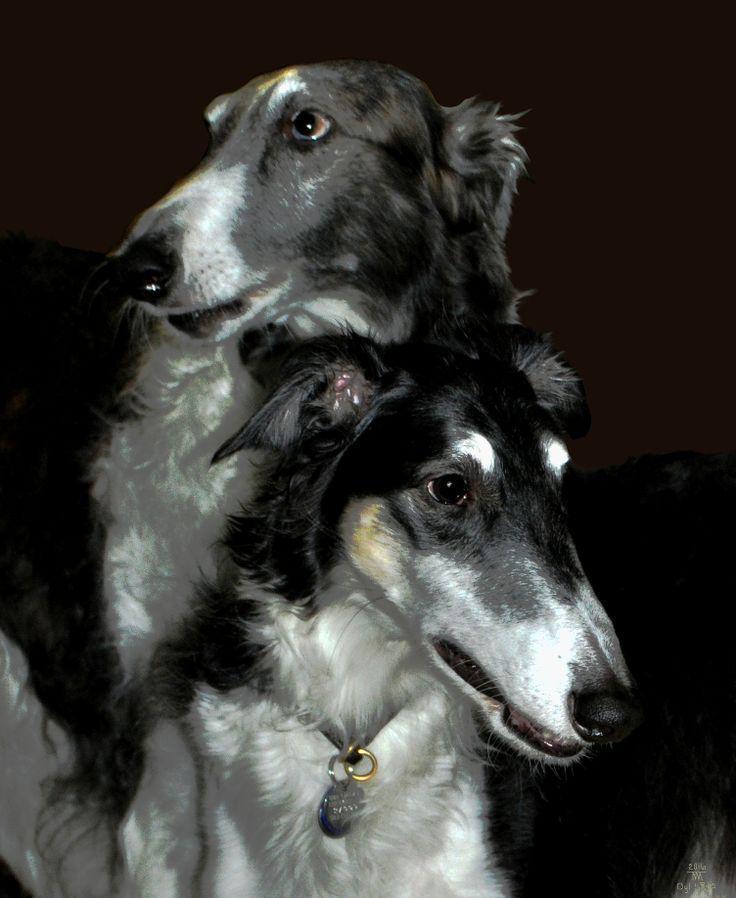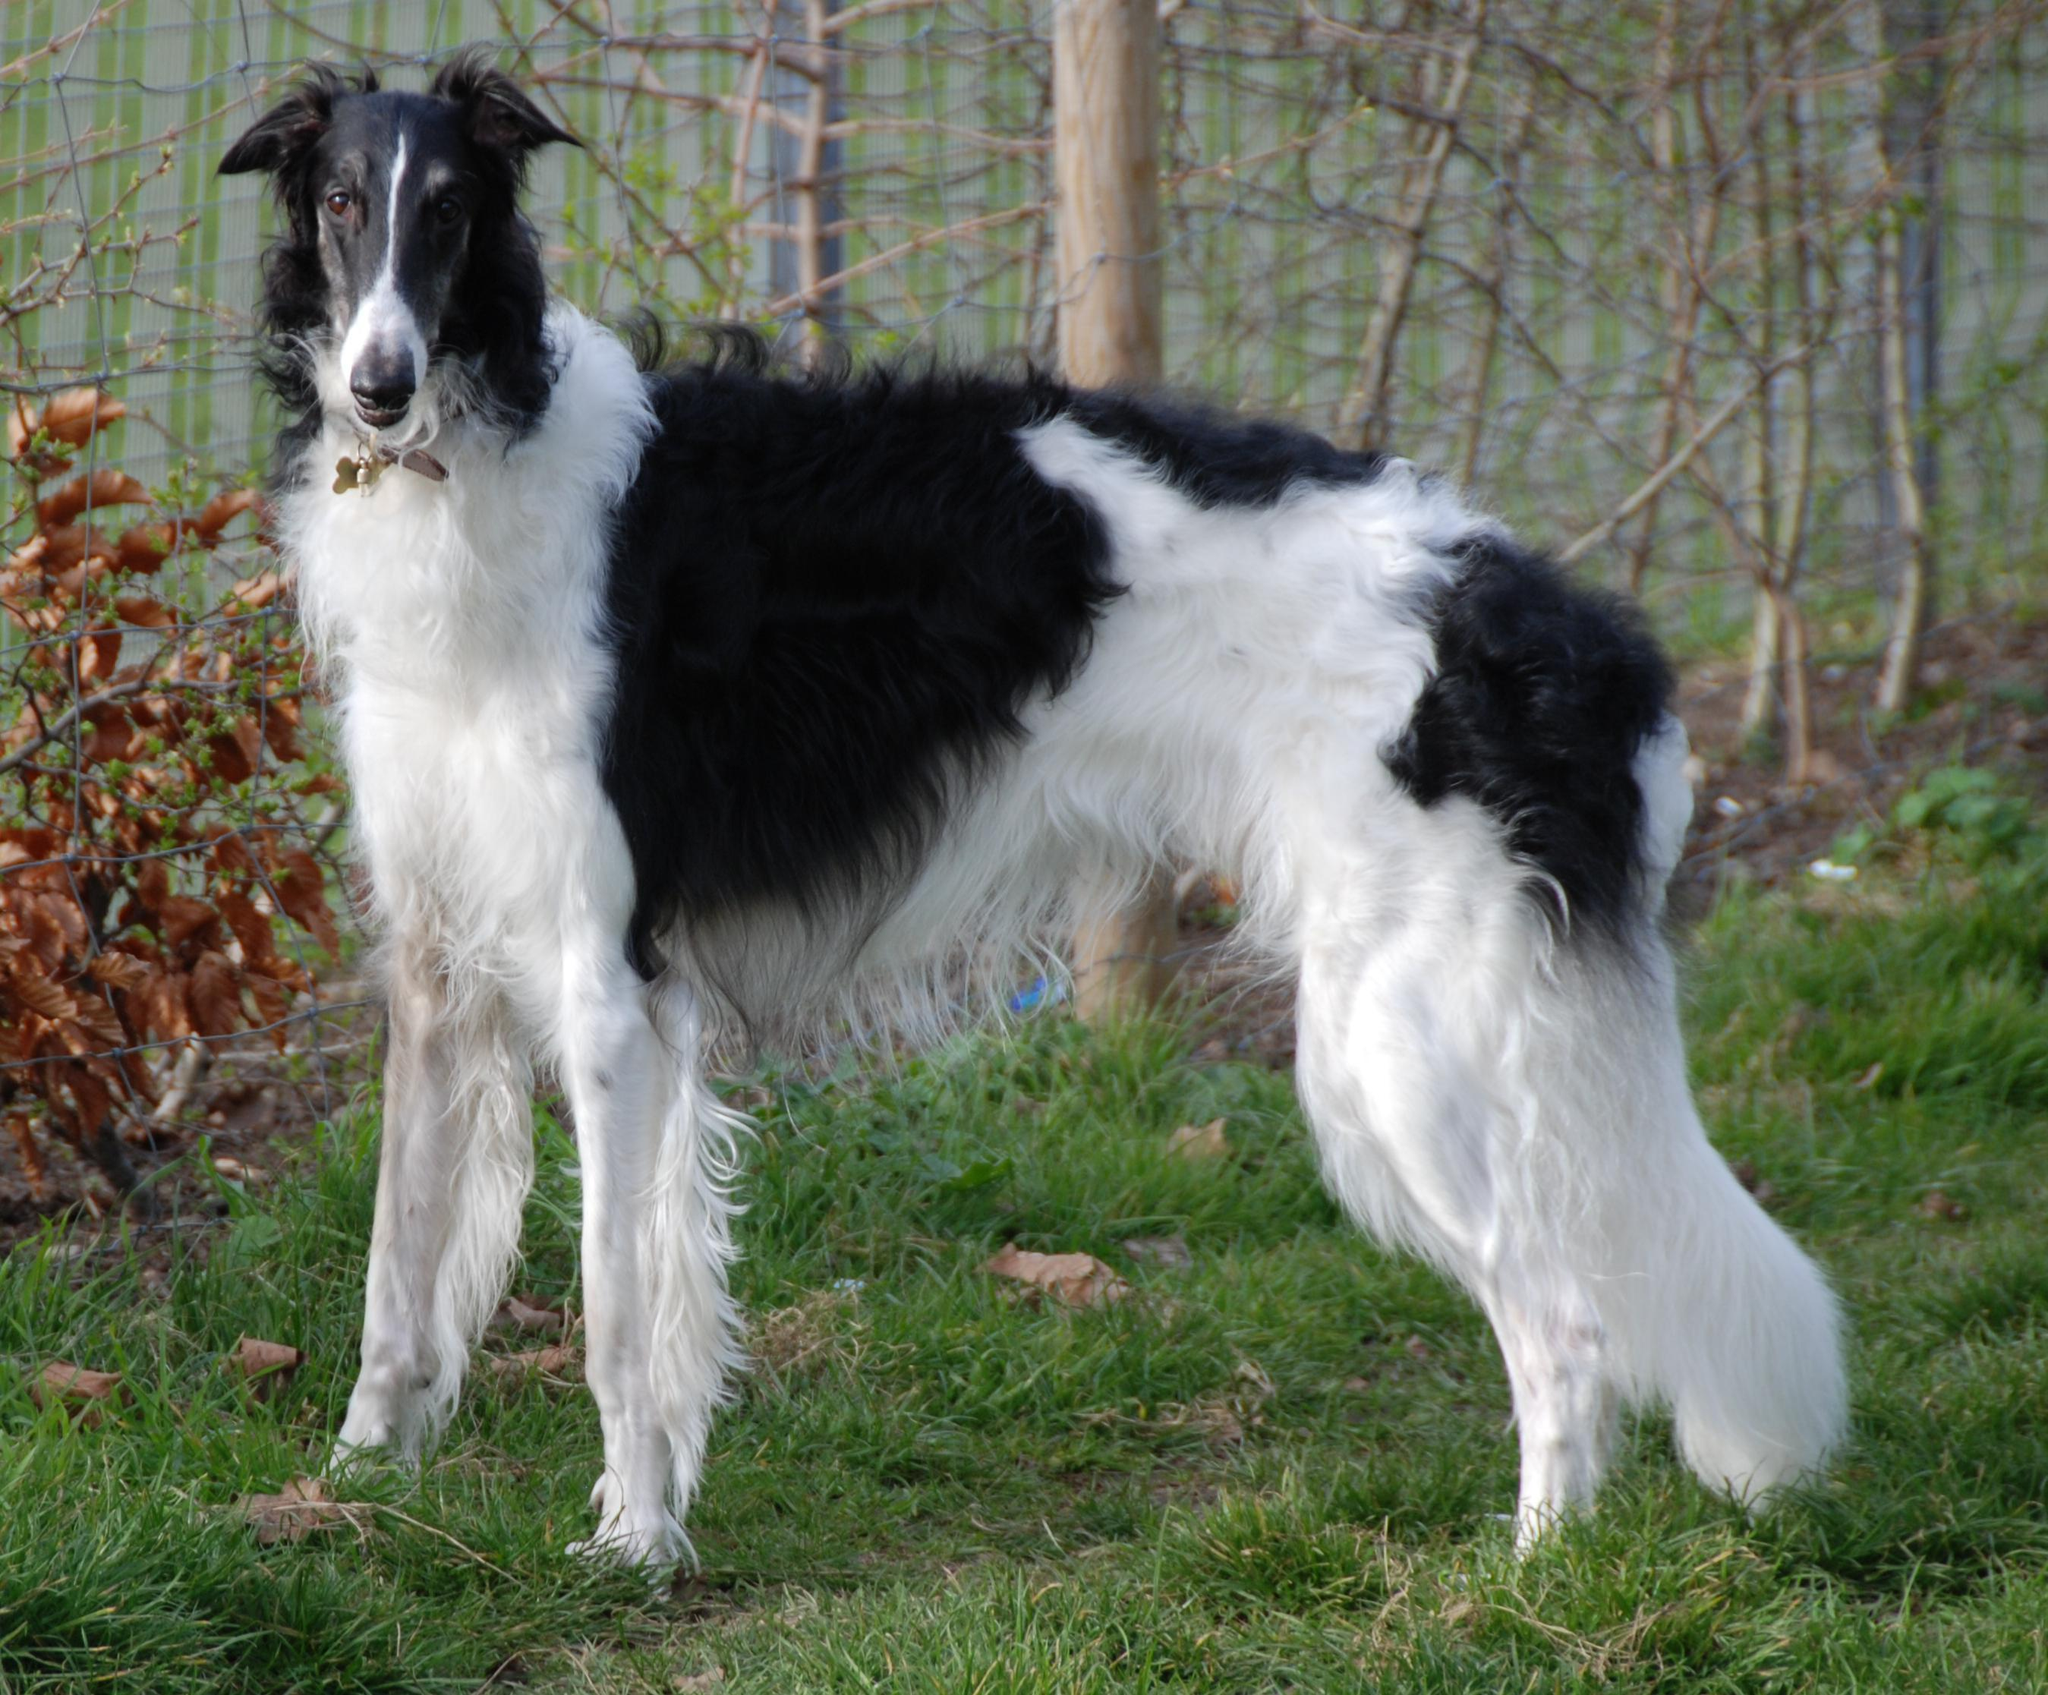The first image is the image on the left, the second image is the image on the right. Evaluate the accuracy of this statement regarding the images: "An image shows one hound standing still with its body in profile and tail hanging down.". Is it true? Answer yes or no. Yes. The first image is the image on the left, the second image is the image on the right. Assess this claim about the two images: "Two white pointy nosed dogs are shown.". Correct or not? Answer yes or no. No. 